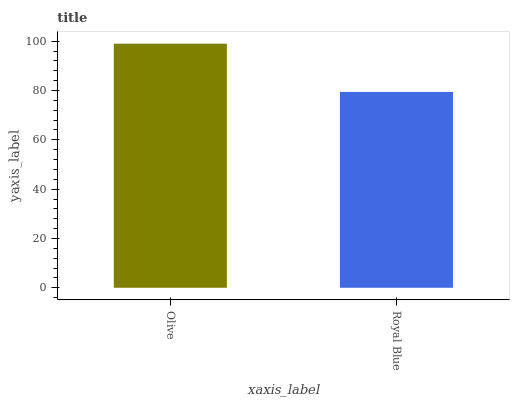Is Royal Blue the maximum?
Answer yes or no. No. Is Olive greater than Royal Blue?
Answer yes or no. Yes. Is Royal Blue less than Olive?
Answer yes or no. Yes. Is Royal Blue greater than Olive?
Answer yes or no. No. Is Olive less than Royal Blue?
Answer yes or no. No. Is Olive the high median?
Answer yes or no. Yes. Is Royal Blue the low median?
Answer yes or no. Yes. Is Royal Blue the high median?
Answer yes or no. No. Is Olive the low median?
Answer yes or no. No. 